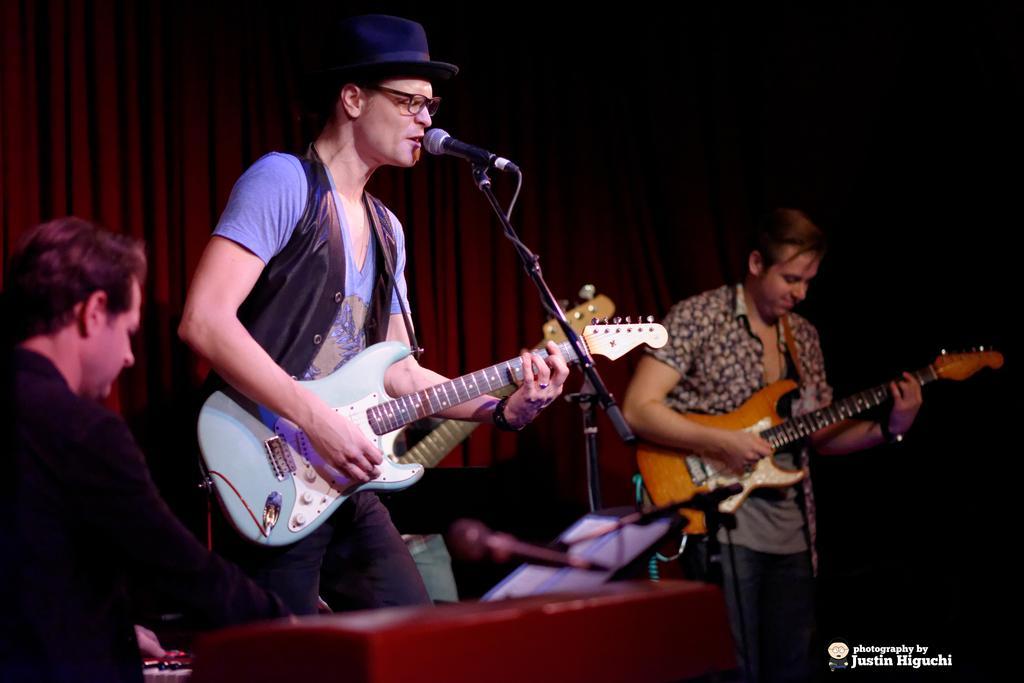How would you summarize this image in a sentence or two? In this image I can see few people are standing and holding guitars. I can also he is wearing a specs and a hat. I can also see a mic and he is wearing a jacket. 